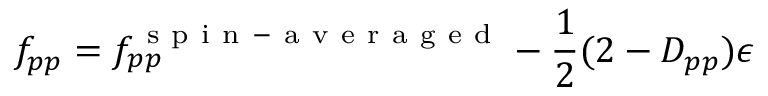Convert formula to latex. <formula><loc_0><loc_0><loc_500><loc_500>f _ { p p } = f _ { p p } ^ { s p i n - a v e r a g e d } - \frac { 1 } { 2 } ( 2 - D _ { p p } ) \epsilon</formula> 